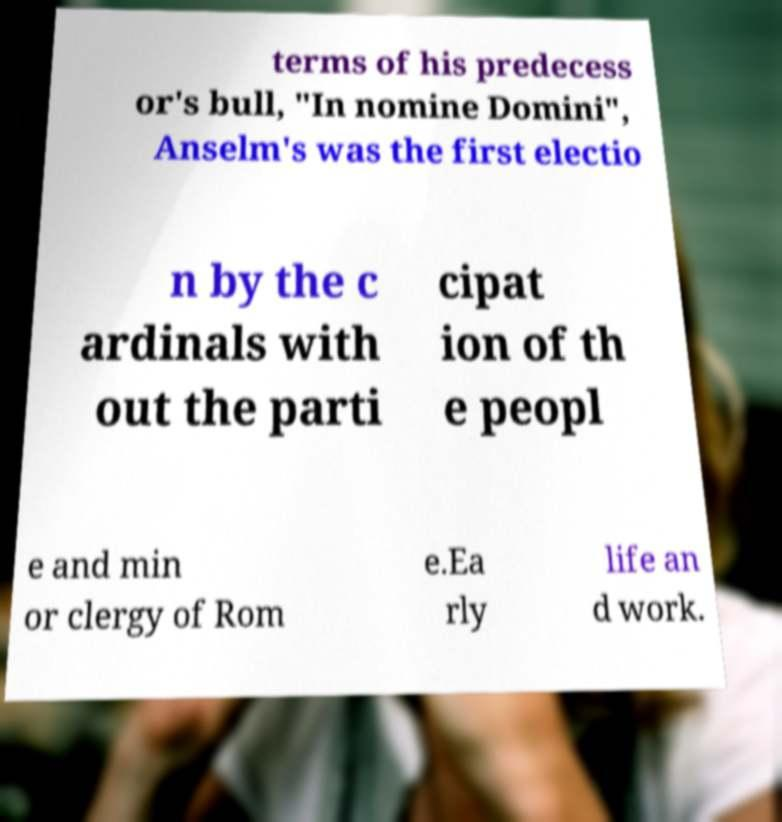Please identify and transcribe the text found in this image. terms of his predecess or's bull, "In nomine Domini", Anselm's was the first electio n by the c ardinals with out the parti cipat ion of th e peopl e and min or clergy of Rom e.Ea rly life an d work. 